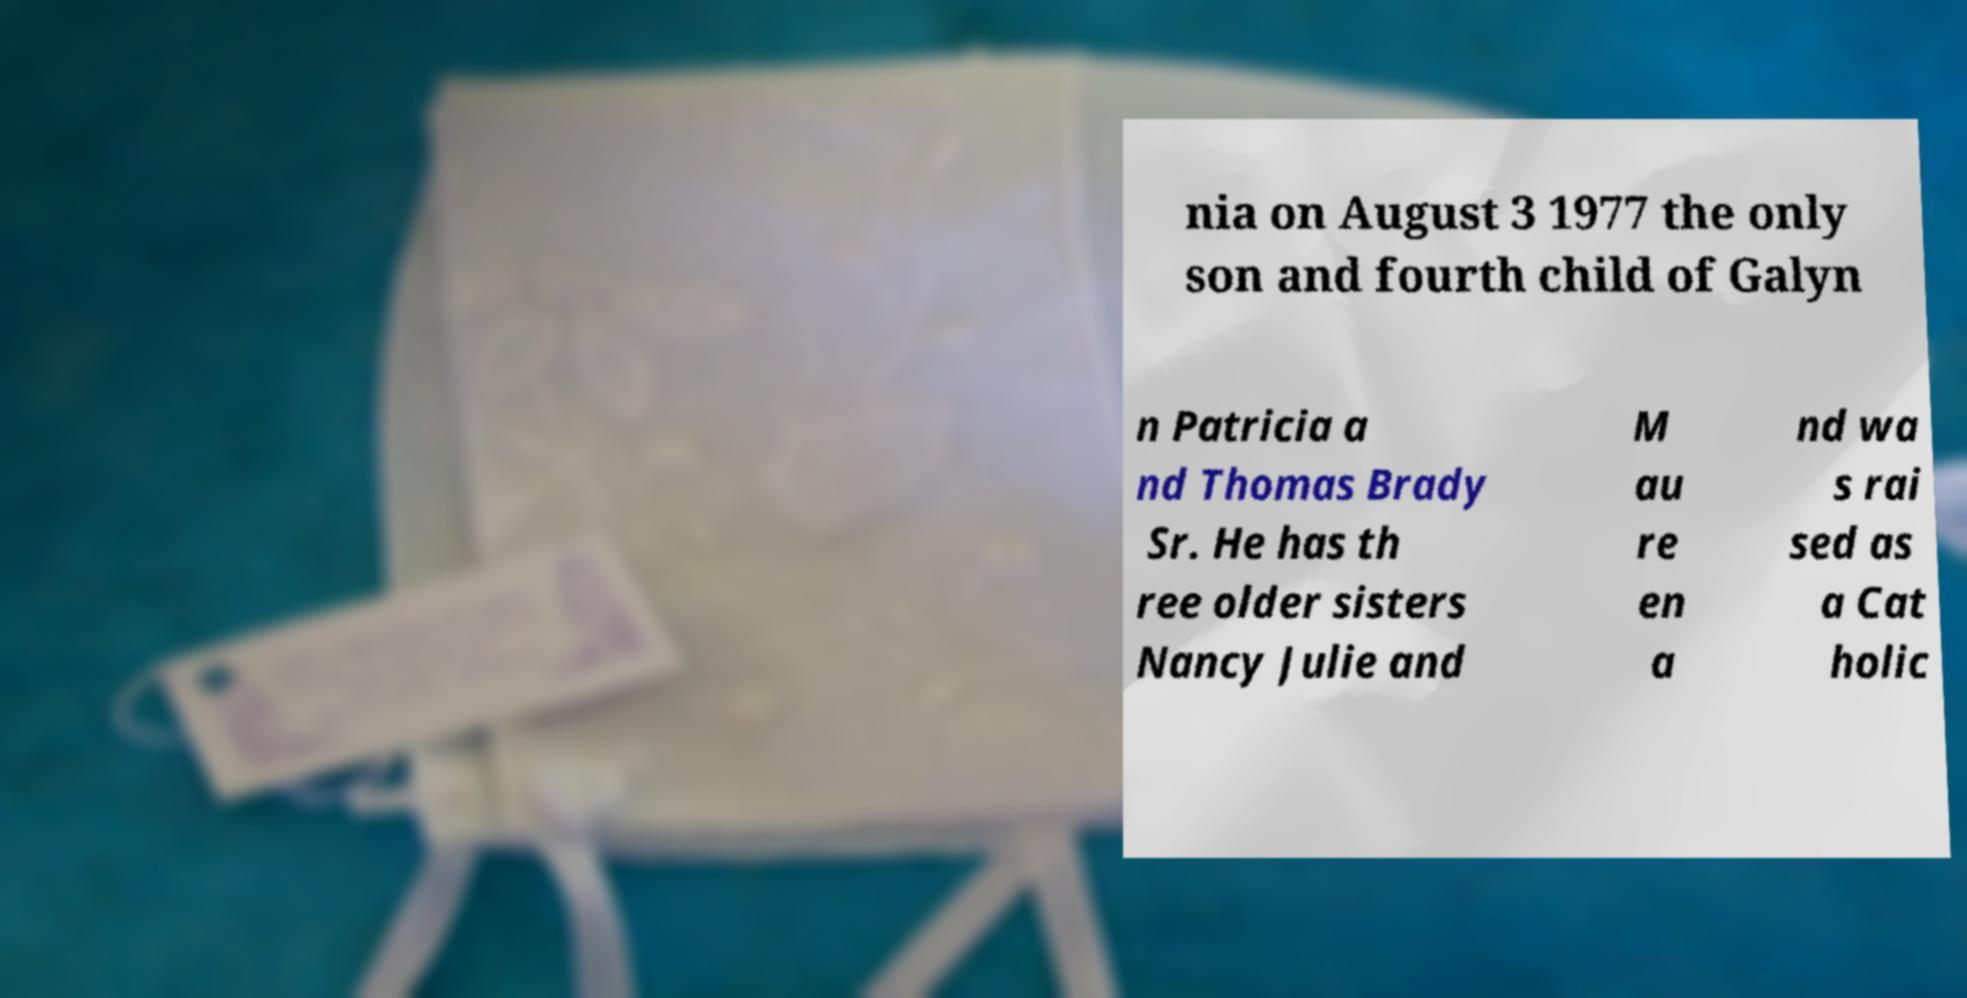Could you assist in decoding the text presented in this image and type it out clearly? nia on August 3 1977 the only son and fourth child of Galyn n Patricia a nd Thomas Brady Sr. He has th ree older sisters Nancy Julie and M au re en a nd wa s rai sed as a Cat holic 